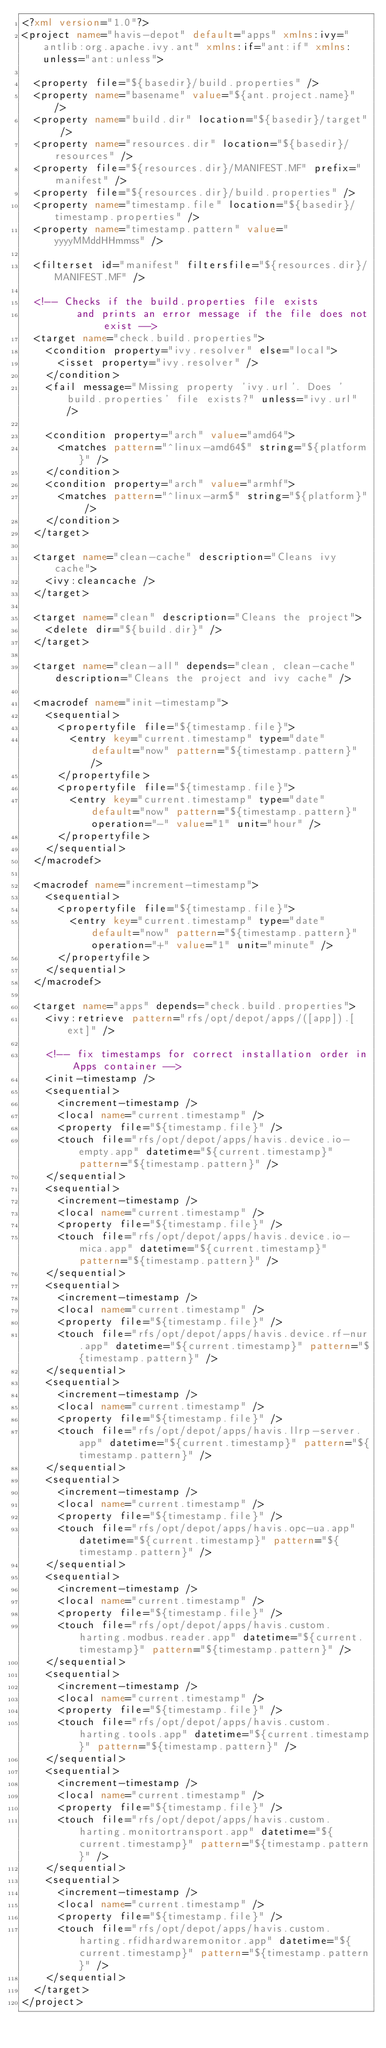<code> <loc_0><loc_0><loc_500><loc_500><_XML_><?xml version="1.0"?>
<project name="havis-depot" default="apps" xmlns:ivy="antlib:org.apache.ivy.ant" xmlns:if="ant:if" xmlns:unless="ant:unless">

	<property file="${basedir}/build.properties" />
	<property name="basename" value="${ant.project.name}" />
	<property name="build.dir" location="${basedir}/target" />
	<property name="resources.dir" location="${basedir}/resources" />
	<property file="${resources.dir}/MANIFEST.MF" prefix="manifest" />
	<property file="${resources.dir}/build.properties" />
	<property name="timestamp.file" location="${basedir}/timestamp.properties" />
	<property name="timestamp.pattern" value="yyyyMMddHHmmss" />

	<filterset id="manifest" filtersfile="${resources.dir}/MANIFEST.MF" />

	<!-- Checks if the build.properties file exists 
         and prints an error message if the file does not exist -->
	<target name="check.build.properties">
		<condition property="ivy.resolver" else="local">
			<isset property="ivy.resolver" />
		</condition>
		<fail message="Missing property 'ivy.url'. Does 'build.properties' file exists?" unless="ivy.url" />

		<condition property="arch" value="amd64">
			<matches pattern="^linux-amd64$" string="${platform}" />
		</condition>
		<condition property="arch" value="armhf">
			<matches pattern="^linux-arm$" string="${platform}" />
		</condition>
	</target>

	<target name="clean-cache" description="Cleans ivy cache">
		<ivy:cleancache />
	</target>

	<target name="clean" description="Cleans the project">
		<delete dir="${build.dir}" />
	</target>

	<target name="clean-all" depends="clean, clean-cache" description="Cleans the project and ivy cache" />
	
	<macrodef name="init-timestamp">
		<sequential>
			<propertyfile file="${timestamp.file}">
				<entry key="current.timestamp" type="date" default="now" pattern="${timestamp.pattern}" />
			</propertyfile>
			<propertyfile file="${timestamp.file}">
				<entry key="current.timestamp" type="date" default="now" pattern="${timestamp.pattern}" operation="-" value="1" unit="hour" />
			</propertyfile>
		</sequential>
	</macrodef>

	<macrodef name="increment-timestamp">
		<sequential>
			<propertyfile file="${timestamp.file}">
				<entry key="current.timestamp" type="date" default="now" pattern="${timestamp.pattern}" operation="+" value="1" unit="minute" />
			</propertyfile>
		</sequential>
	</macrodef>

	<target name="apps" depends="check.build.properties">
		<ivy:retrieve pattern="rfs/opt/depot/apps/([app]).[ext]" />

		<!-- fix timestamps for correct installation order in Apps container -->
		<init-timestamp />
		<sequential>
			<increment-timestamp />
			<local name="current.timestamp" />
			<property file="${timestamp.file}" />
			<touch file="rfs/opt/depot/apps/havis.device.io-empty.app" datetime="${current.timestamp}" pattern="${timestamp.pattern}" />
		</sequential>
		<sequential>
			<increment-timestamp />
			<local name="current.timestamp" />
			<property file="${timestamp.file}" />
			<touch file="rfs/opt/depot/apps/havis.device.io-mica.app" datetime="${current.timestamp}" pattern="${timestamp.pattern}" />
		</sequential>
		<sequential>
			<increment-timestamp />
			<local name="current.timestamp" />
			<property file="${timestamp.file}" />
			<touch file="rfs/opt/depot/apps/havis.device.rf-nur.app" datetime="${current.timestamp}" pattern="${timestamp.pattern}" />
		</sequential>
		<sequential>
			<increment-timestamp />
			<local name="current.timestamp" />
			<property file="${timestamp.file}" />
			<touch file="rfs/opt/depot/apps/havis.llrp-server.app" datetime="${current.timestamp}" pattern="${timestamp.pattern}" />
		</sequential>
		<sequential>
			<increment-timestamp />
			<local name="current.timestamp" />
			<property file="${timestamp.file}" />
			<touch file="rfs/opt/depot/apps/havis.opc-ua.app" datetime="${current.timestamp}" pattern="${timestamp.pattern}" />
		</sequential>
		<sequential>
			<increment-timestamp />
			<local name="current.timestamp" />
			<property file="${timestamp.file}" />
			<touch file="rfs/opt/depot/apps/havis.custom.harting.modbus.reader.app" datetime="${current.timestamp}" pattern="${timestamp.pattern}" />
		</sequential>
		<sequential>
			<increment-timestamp />
			<local name="current.timestamp" />
			<property file="${timestamp.file}" />
			<touch file="rfs/opt/depot/apps/havis.custom.harting.tools.app" datetime="${current.timestamp}" pattern="${timestamp.pattern}" />
		</sequential>
		<sequential>
			<increment-timestamp />
			<local name="current.timestamp" />
			<property file="${timestamp.file}" />
			<touch file="rfs/opt/depot/apps/havis.custom.harting.monitortransport.app" datetime="${current.timestamp}" pattern="${timestamp.pattern}" />
		</sequential>
		<sequential>
			<increment-timestamp />
			<local name="current.timestamp" />
			<property file="${timestamp.file}" />
			<touch file="rfs/opt/depot/apps/havis.custom.harting.rfidhardwaremonitor.app" datetime="${current.timestamp}" pattern="${timestamp.pattern}" />
		</sequential>
	</target>
</project>
</code> 